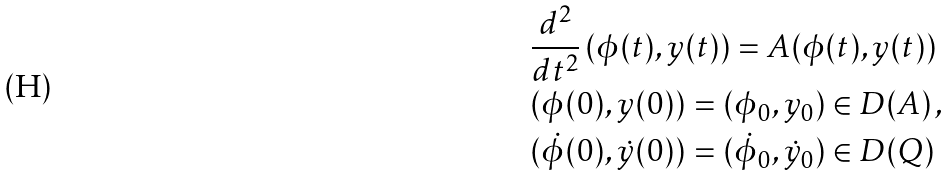<formula> <loc_0><loc_0><loc_500><loc_500>& \frac { d ^ { 2 } } { d t ^ { 2 } } \, ( \phi ( t ) , y ( t ) ) = A ( \phi ( t ) , y ( t ) ) \\ & ( \phi ( 0 ) , y ( 0 ) ) = ( \phi _ { 0 } , y _ { 0 } ) \in D ( A ) \, , \\ & ( \dot { \phi } ( 0 ) , \dot { y } ( 0 ) ) = ( \dot { \phi } _ { 0 } , \dot { y } _ { 0 } ) \in D ( Q )</formula> 